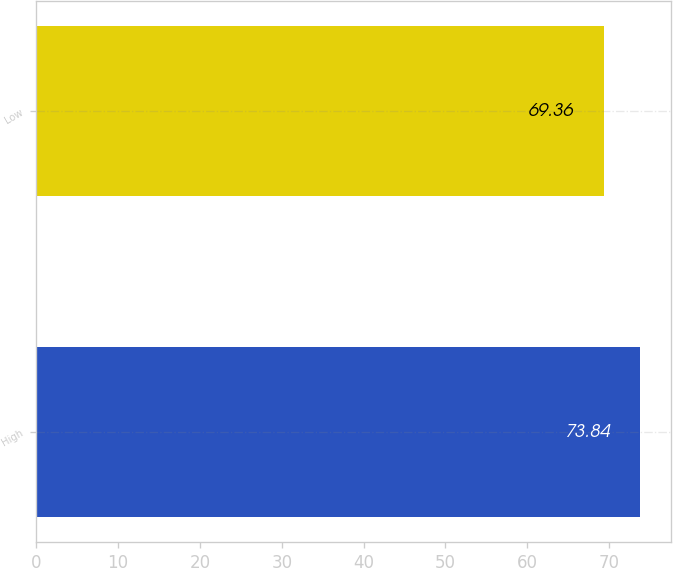Convert chart to OTSL. <chart><loc_0><loc_0><loc_500><loc_500><bar_chart><fcel>High<fcel>Low<nl><fcel>73.84<fcel>69.36<nl></chart> 